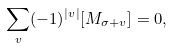Convert formula to latex. <formula><loc_0><loc_0><loc_500><loc_500>\sum _ { v } ( - 1 ) ^ { | v | } [ M _ { \sigma + v } ] = 0 ,</formula> 